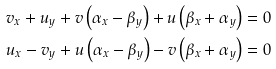<formula> <loc_0><loc_0><loc_500><loc_500>& { { v } _ { x } } + { { u } _ { y } } + v \left ( { { \alpha } _ { x } } - { { \beta } _ { y } } \right ) + u \left ( { { \beta } _ { x } } + { { \alpha } _ { y } } \right ) = 0 \\ & { { u } _ { x } } - { { v } _ { y } } + u \left ( { { \alpha } _ { x } } - { { \beta } _ { y } } \right ) - v \left ( { { \beta } _ { x } } + { { \alpha } _ { y } } \right ) = 0</formula> 